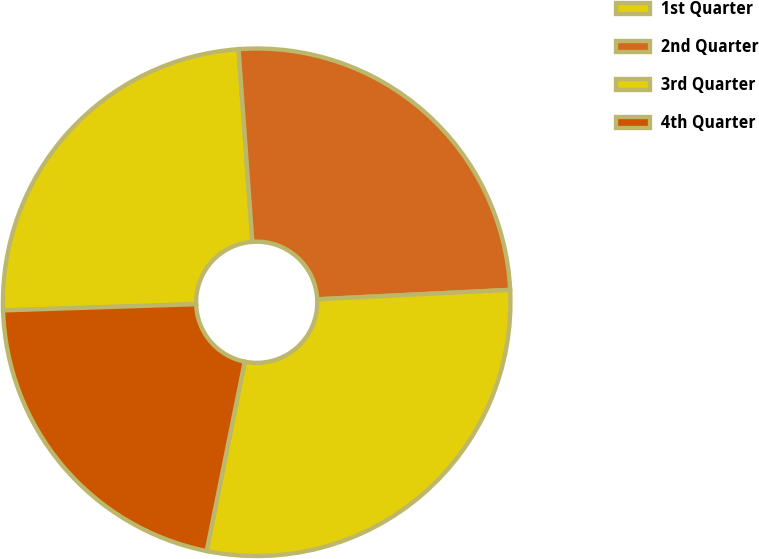<chart> <loc_0><loc_0><loc_500><loc_500><pie_chart><fcel>1st Quarter<fcel>2nd Quarter<fcel>3rd Quarter<fcel>4th Quarter<nl><fcel>24.37%<fcel>25.36%<fcel>28.94%<fcel>21.33%<nl></chart> 